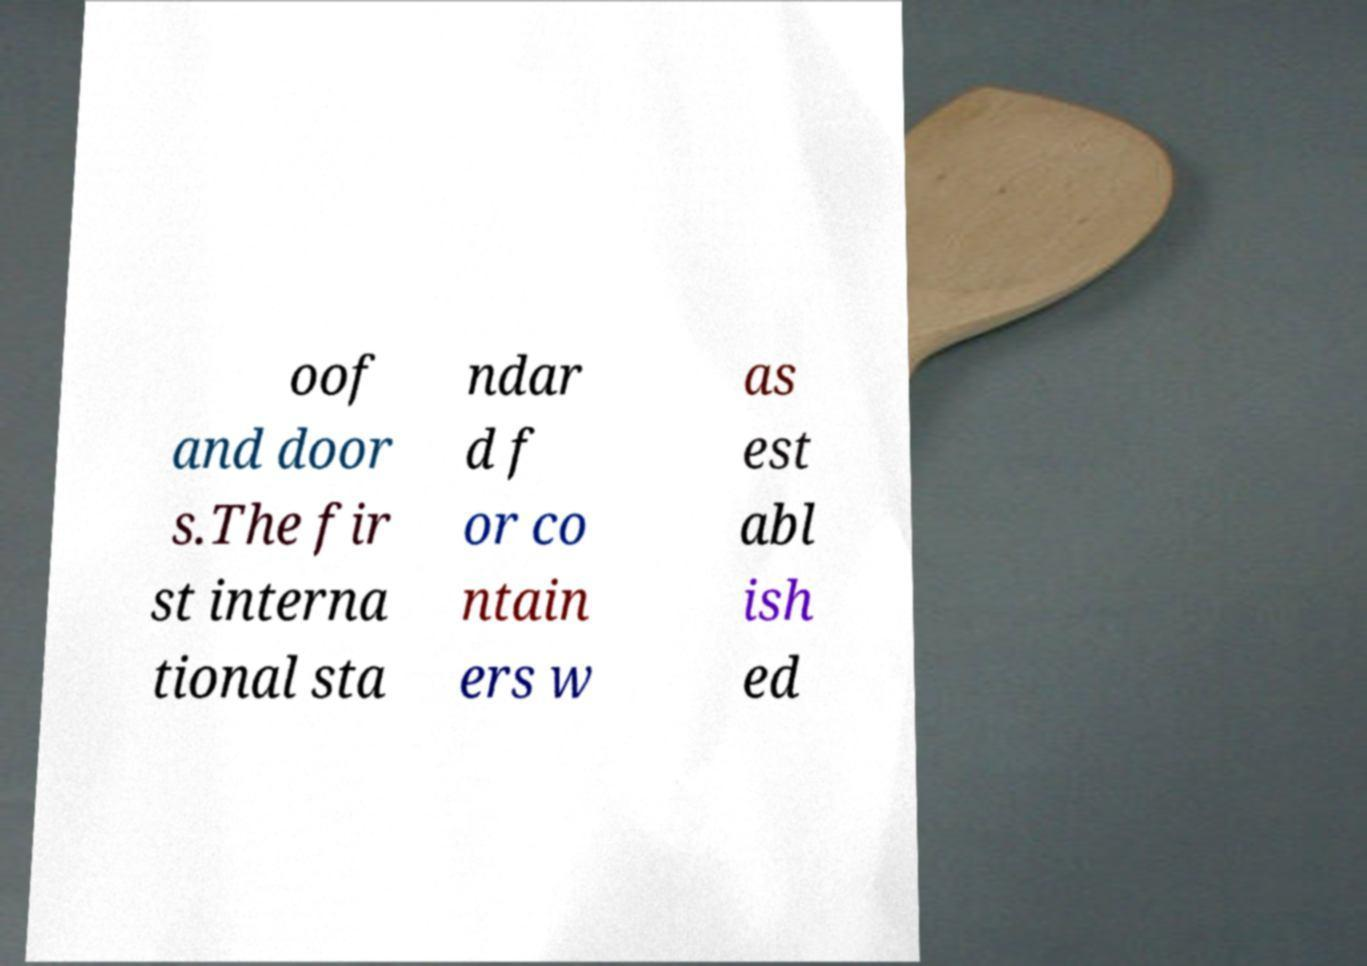Could you assist in decoding the text presented in this image and type it out clearly? oof and door s.The fir st interna tional sta ndar d f or co ntain ers w as est abl ish ed 